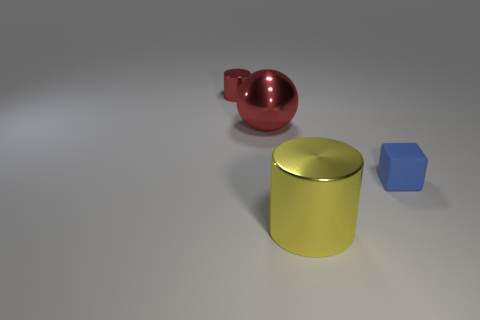Add 4 small metallic things. How many objects exist? 8 Subtract all cubes. How many objects are left? 3 Add 3 big red things. How many big red things are left? 4 Add 4 cyan balls. How many cyan balls exist? 4 Subtract 0 blue balls. How many objects are left? 4 Subtract all tiny rubber cubes. Subtract all red things. How many objects are left? 1 